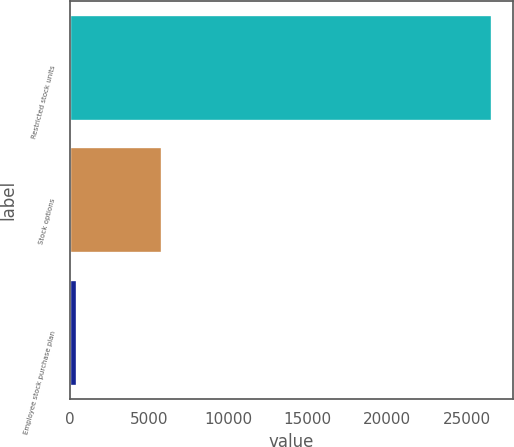Convert chart to OTSL. <chart><loc_0><loc_0><loc_500><loc_500><bar_chart><fcel>Restricted stock units<fcel>Stock options<fcel>Employee stock purchase plan<nl><fcel>26570<fcel>5829<fcel>467<nl></chart> 